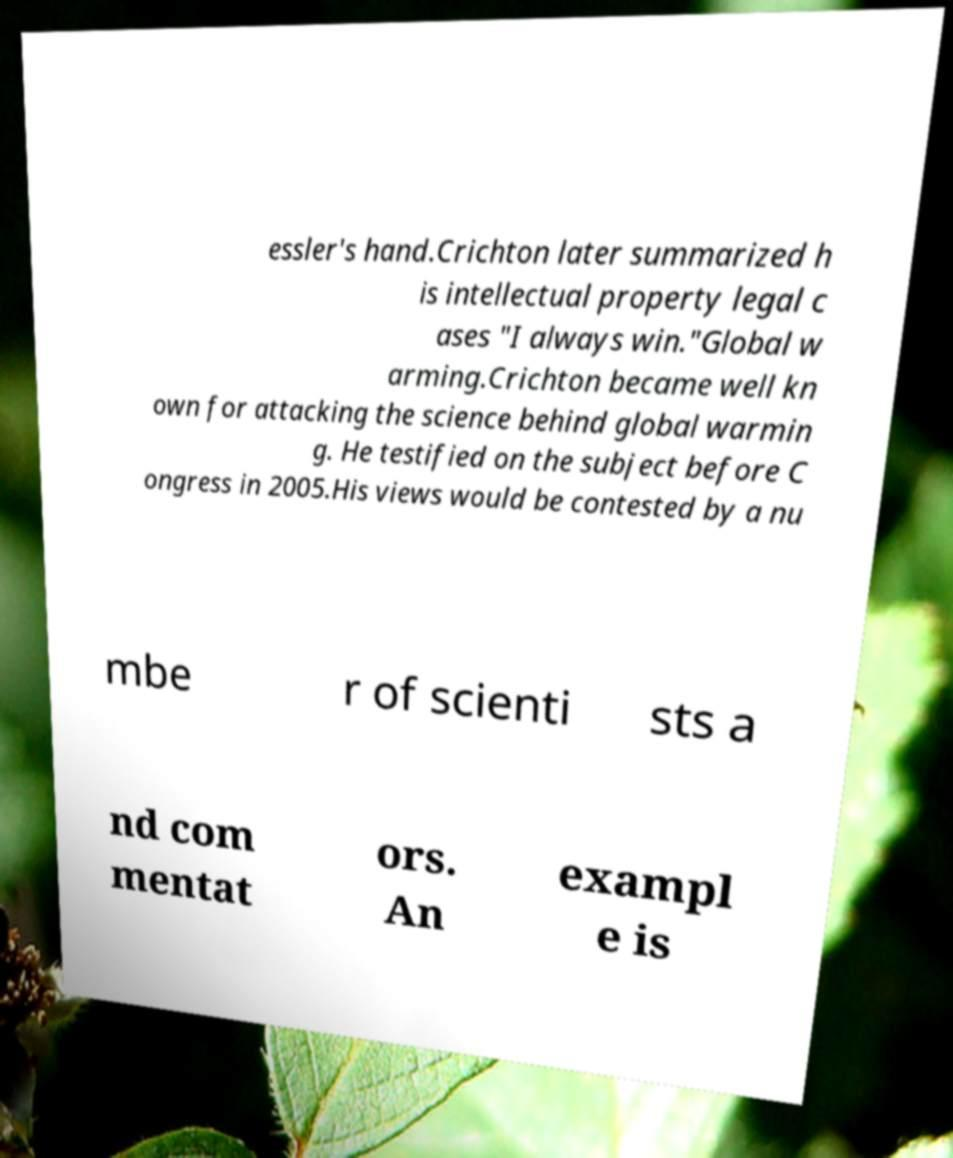For documentation purposes, I need the text within this image transcribed. Could you provide that? essler's hand.Crichton later summarized h is intellectual property legal c ases "I always win."Global w arming.Crichton became well kn own for attacking the science behind global warmin g. He testified on the subject before C ongress in 2005.His views would be contested by a nu mbe r of scienti sts a nd com mentat ors. An exampl e is 